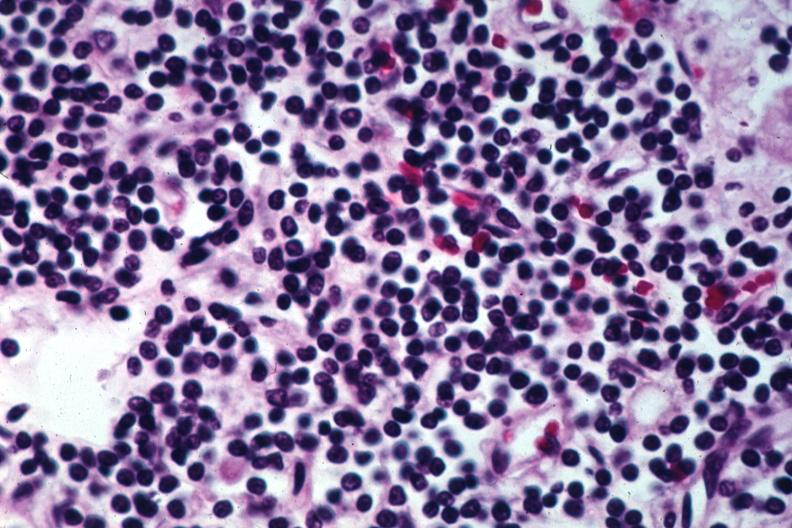what is present?
Answer the question using a single word or phrase. Chronic lymphocytic leukemia 